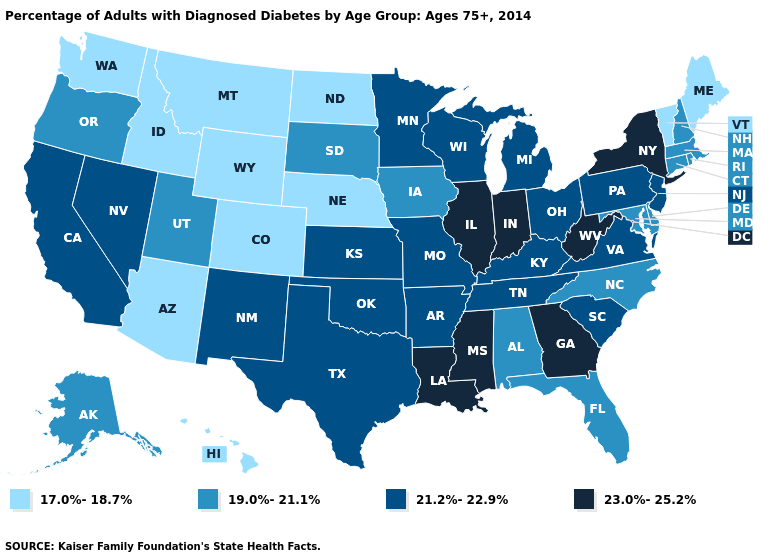What is the value of Vermont?
Quick response, please. 17.0%-18.7%. What is the value of California?
Short answer required. 21.2%-22.9%. Which states have the lowest value in the West?
Concise answer only. Arizona, Colorado, Hawaii, Idaho, Montana, Washington, Wyoming. Which states have the highest value in the USA?
Keep it brief. Georgia, Illinois, Indiana, Louisiana, Mississippi, New York, West Virginia. Among the states that border Delaware , does Maryland have the highest value?
Give a very brief answer. No. Does the map have missing data?
Quick response, please. No. Name the states that have a value in the range 17.0%-18.7%?
Write a very short answer. Arizona, Colorado, Hawaii, Idaho, Maine, Montana, Nebraska, North Dakota, Vermont, Washington, Wyoming. Among the states that border South Carolina , which have the highest value?
Quick response, please. Georgia. What is the value of Pennsylvania?
Answer briefly. 21.2%-22.9%. Does the map have missing data?
Give a very brief answer. No. Which states have the highest value in the USA?
Concise answer only. Georgia, Illinois, Indiana, Louisiana, Mississippi, New York, West Virginia. Name the states that have a value in the range 23.0%-25.2%?
Keep it brief. Georgia, Illinois, Indiana, Louisiana, Mississippi, New York, West Virginia. What is the value of Kansas?
Keep it brief. 21.2%-22.9%. Name the states that have a value in the range 21.2%-22.9%?
Keep it brief. Arkansas, California, Kansas, Kentucky, Michigan, Minnesota, Missouri, Nevada, New Jersey, New Mexico, Ohio, Oklahoma, Pennsylvania, South Carolina, Tennessee, Texas, Virginia, Wisconsin. Among the states that border Indiana , does Michigan have the highest value?
Be succinct. No. 